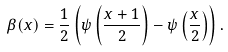<formula> <loc_0><loc_0><loc_500><loc_500>\beta ( x ) = \frac { 1 } { 2 } \left ( \psi \left ( \frac { x + 1 } { 2 } \right ) - \psi \left ( \frac { x } { 2 } \right ) \right ) .</formula> 